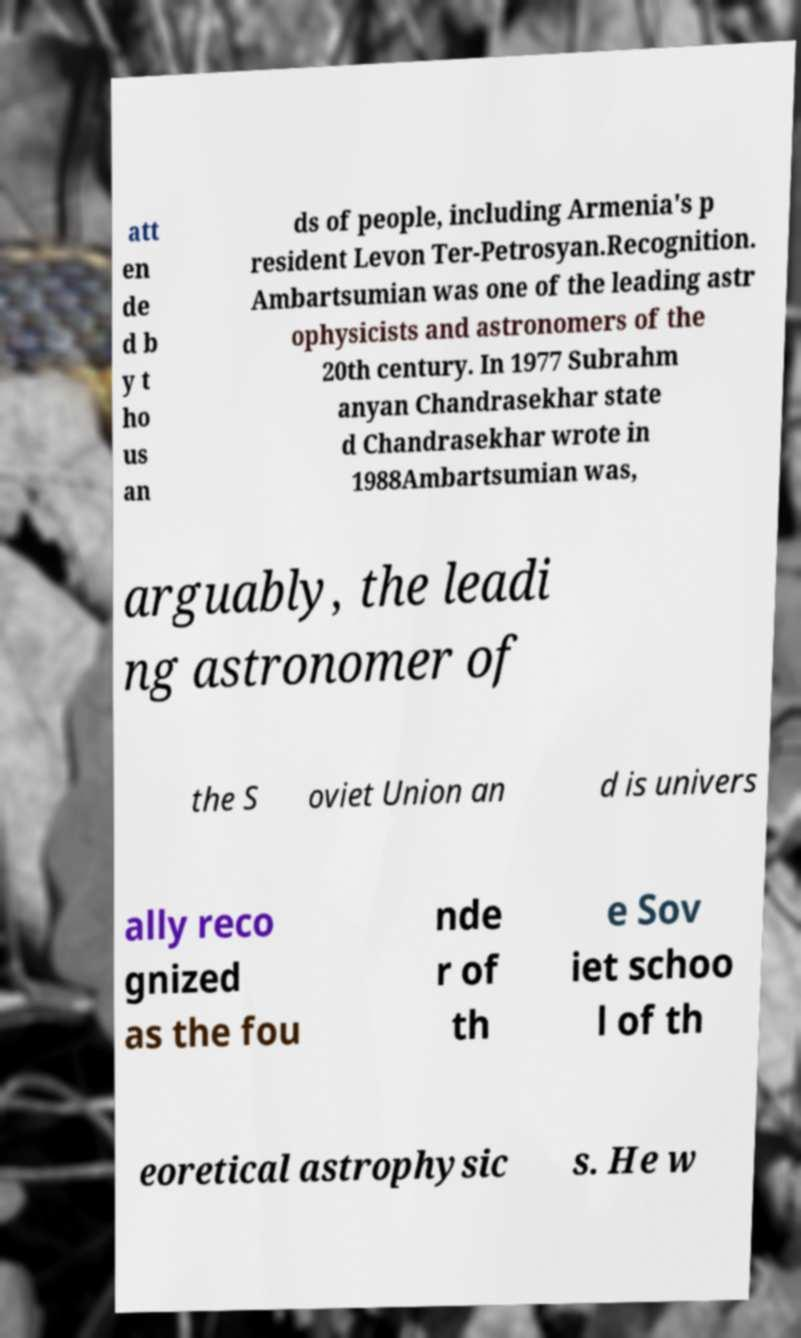Could you extract and type out the text from this image? att en de d b y t ho us an ds of people, including Armenia's p resident Levon Ter-Petrosyan.Recognition. Ambartsumian was one of the leading astr ophysicists and astronomers of the 20th century. In 1977 Subrahm anyan Chandrasekhar state d Chandrasekhar wrote in 1988Ambartsumian was, arguably, the leadi ng astronomer of the S oviet Union an d is univers ally reco gnized as the fou nde r of th e Sov iet schoo l of th eoretical astrophysic s. He w 